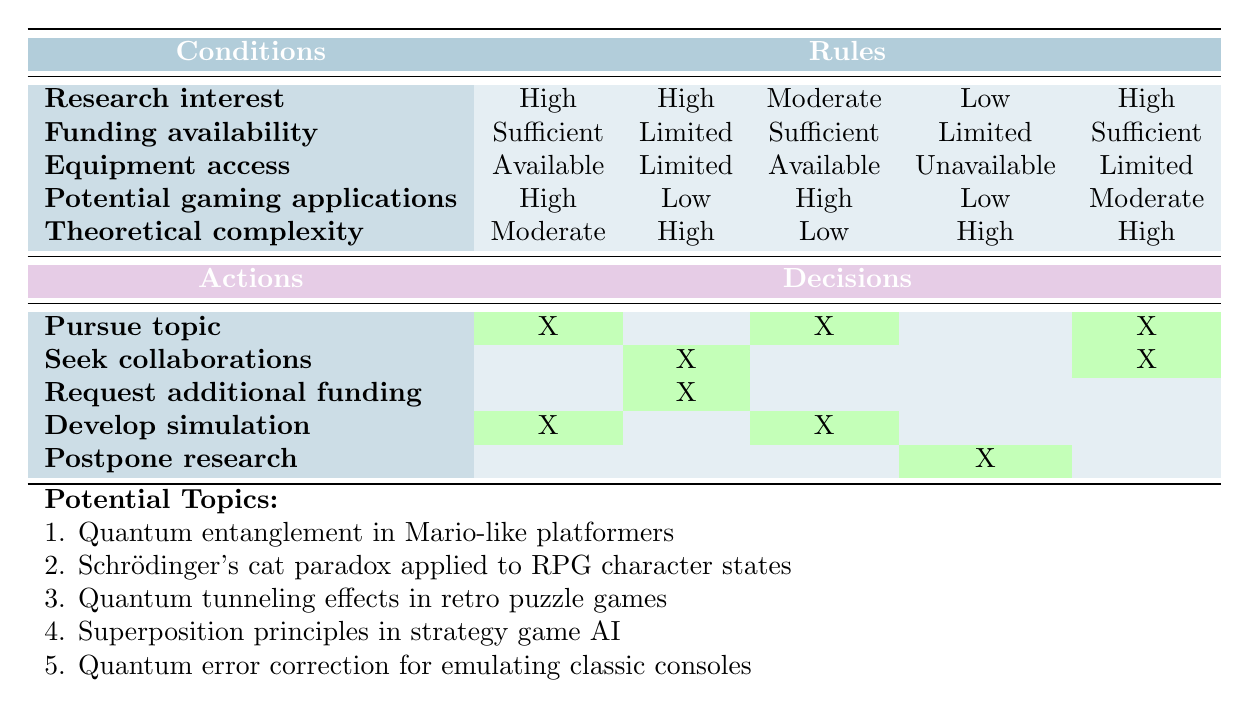What are the actions recommended when research interest is high and funding availability is sufficient? In the table, we locate the row where research interest is "High" and funding availability is "Sufficient." This corresponds to the first and fifth rules. Both rules suggest the actions "Pursue topic" and "Develop simulation."
Answer: Pursue topic, Develop simulation Is there a situation where all conditions are limited? We can look at all the rules in the table to check if there is a scenario where research interest, funding availability, equipment access, potential gaming applications, and theoretical complexity are all "Limited." Reviewing the rules, none of them meet this criterion; therefore, the answer is no.
Answer: No What action should be taken if research interest is low and equipment access is unavailable? We can check the rules section for the conditions of low research interest and unavailable equipment access. There is one rule that fits this condition, and it recommends the action "Postpone research."
Answer: Postpone research Which action is not suggested for high theoretical complexity when funding is limited? To find this, we need to look for rules with "High" theoretical complexity and "Limited" funding availability. The only rule with these characteristics does not suggest "Develop simulation," as it is not included in the action list for this rule.
Answer: Develop simulation How many actions are recommended for a high research interest with limited funding and equipment access? We need to find the row with high research interest, limited funding, and limited equipment access; this corresponds to the second rule. This rule suggests "Seek collaborations" and "Request additional funding," totaling two actions.
Answer: 2 